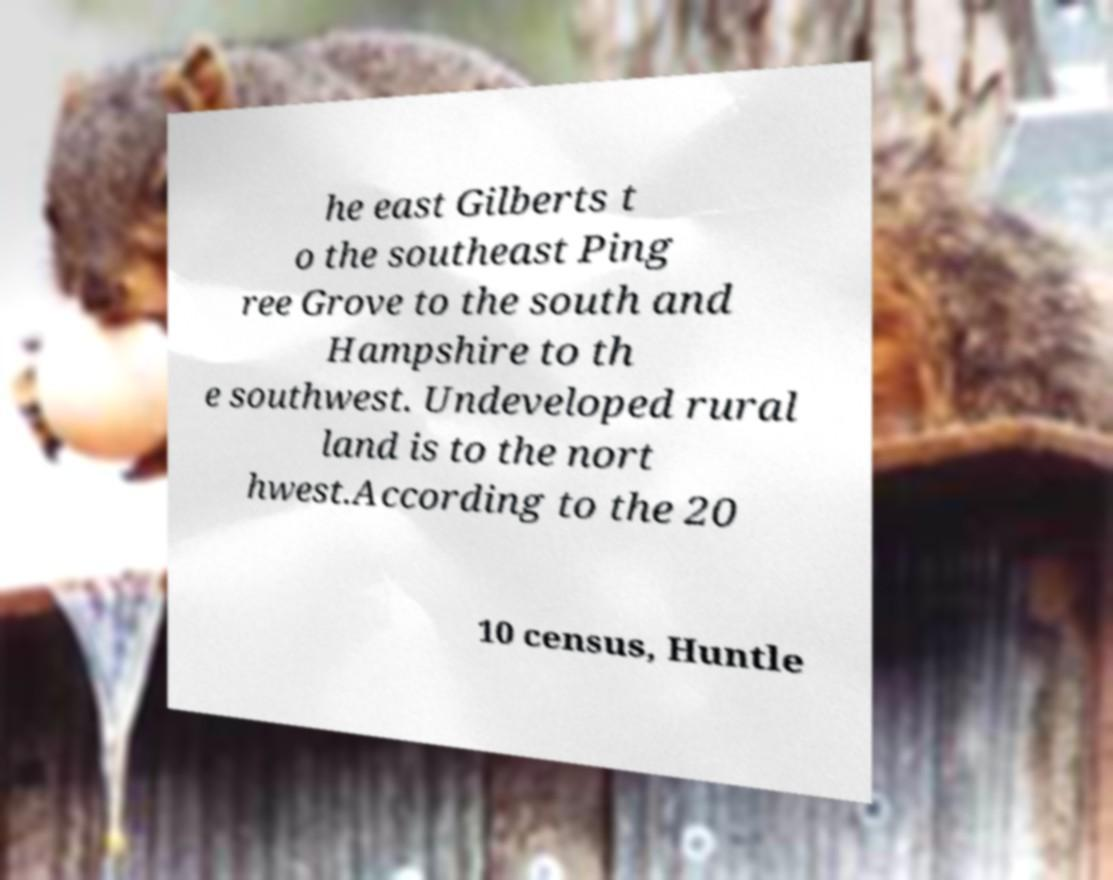I need the written content from this picture converted into text. Can you do that? he east Gilberts t o the southeast Ping ree Grove to the south and Hampshire to th e southwest. Undeveloped rural land is to the nort hwest.According to the 20 10 census, Huntle 